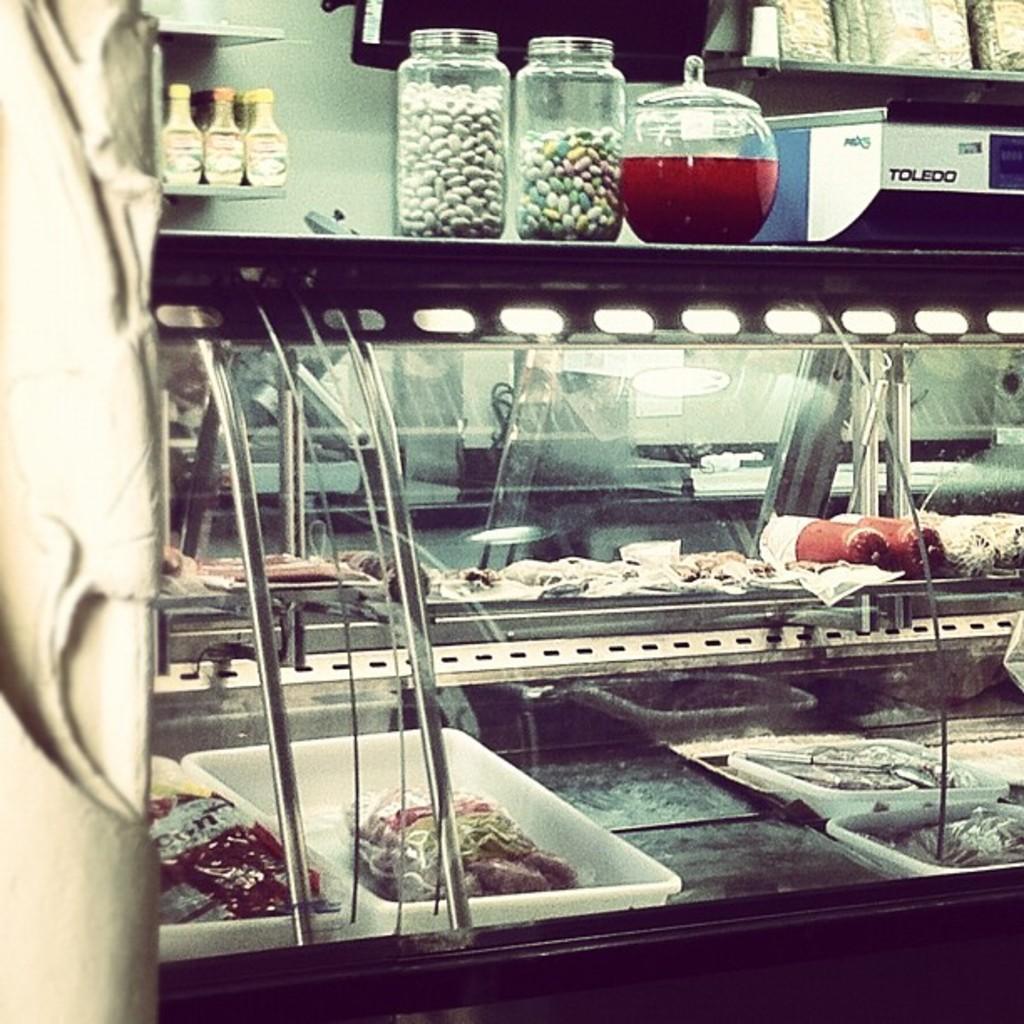Can you describe this image briefly? In this image we can see food items placed in shelves. At the top of the image we can see jars and beverage jar placed on the table. In the background we can see bottles, packets, television and wall. 